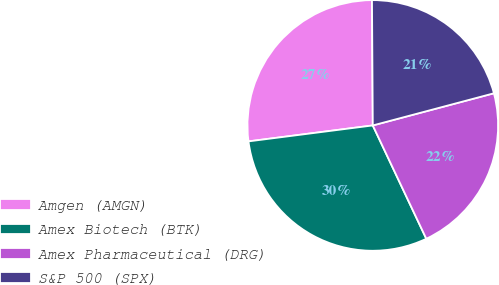<chart> <loc_0><loc_0><loc_500><loc_500><pie_chart><fcel>Amgen (AMGN)<fcel>Amex Biotech (BTK)<fcel>Amex Pharmaceutical (DRG)<fcel>S&P 500 (SPX)<nl><fcel>26.93%<fcel>29.99%<fcel>22.11%<fcel>20.97%<nl></chart> 